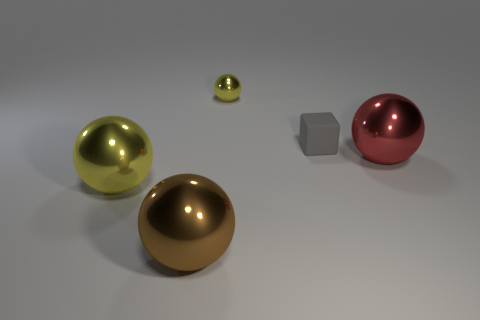Is there any other thing that has the same shape as the gray object?
Make the answer very short. No. The brown ball that is made of the same material as the large red thing is what size?
Keep it short and to the point. Large. Are there more red spheres than large spheres?
Your response must be concise. No. There is another yellow thing that is the same size as the rubber thing; what material is it?
Your answer should be very brief. Metal. Is the size of the yellow shiny thing that is behind the matte block the same as the large red metallic object?
Keep it short and to the point. No. What number of spheres are either small shiny objects or large cyan rubber things?
Make the answer very short. 1. There is a big sphere to the right of the tiny rubber thing; what is it made of?
Ensure brevity in your answer.  Metal. Is the number of small gray spheres less than the number of tiny matte things?
Ensure brevity in your answer.  Yes. What is the size of the metallic ball that is both on the left side of the gray object and on the right side of the big brown shiny ball?
Give a very brief answer. Small. There is a gray matte object that is on the right side of the yellow metal thing that is behind the yellow metallic sphere that is to the left of the large brown object; what is its size?
Give a very brief answer. Small. 